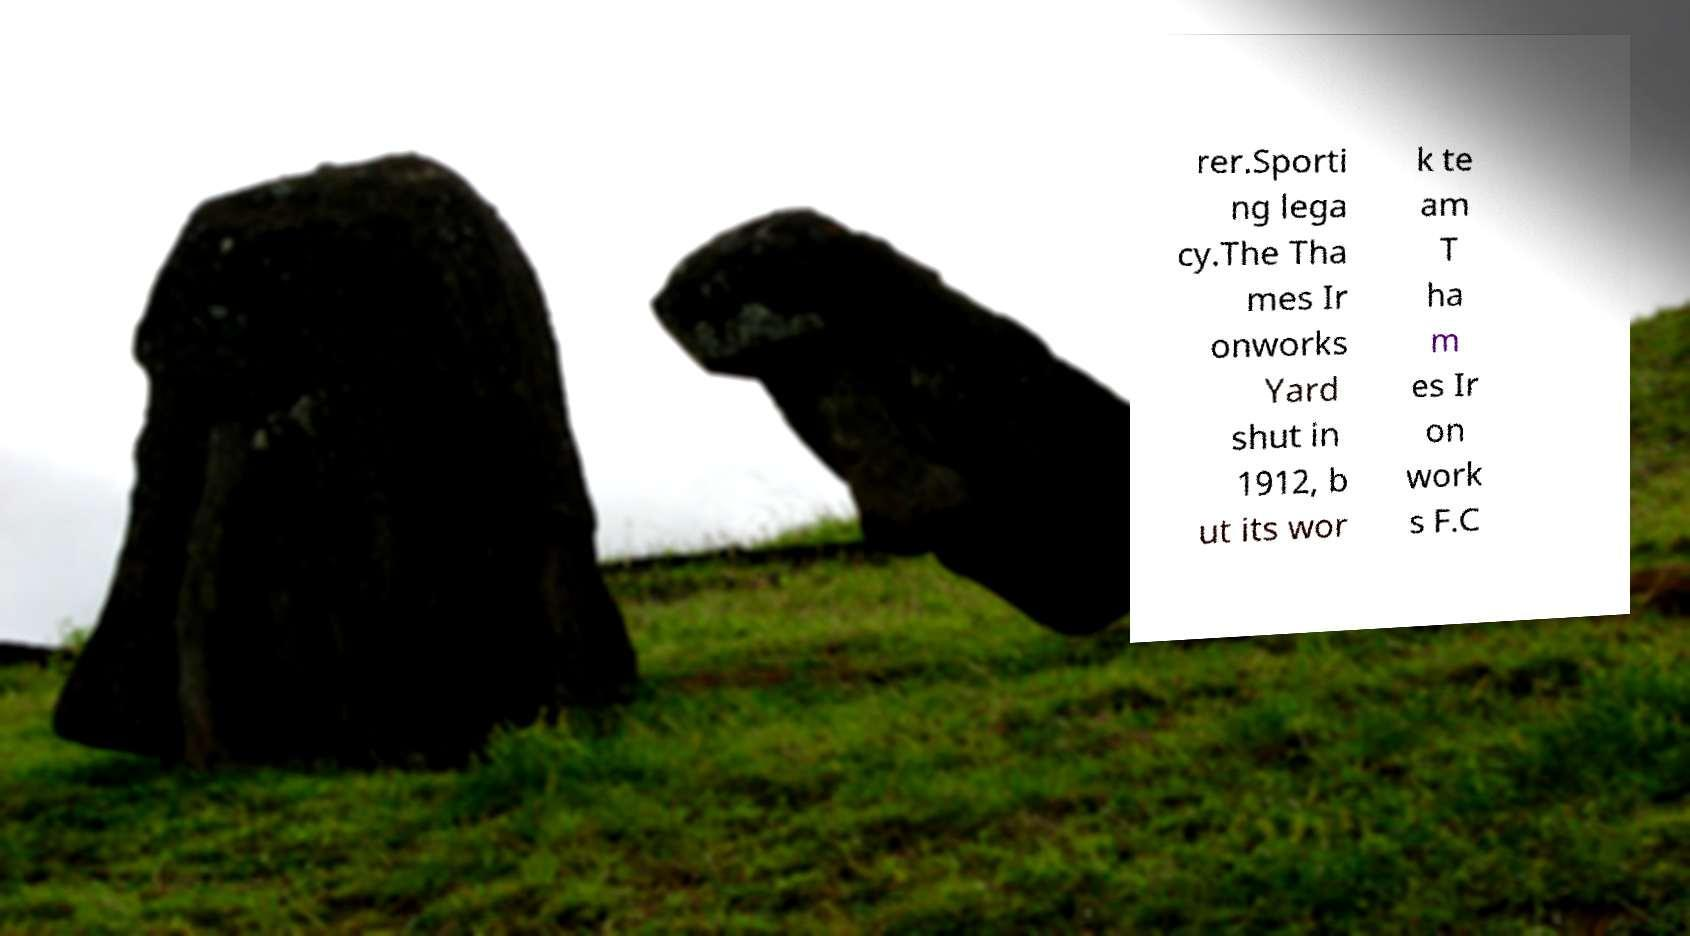Please identify and transcribe the text found in this image. rer.Sporti ng lega cy.The Tha mes Ir onworks Yard shut in 1912, b ut its wor k te am T ha m es Ir on work s F.C 